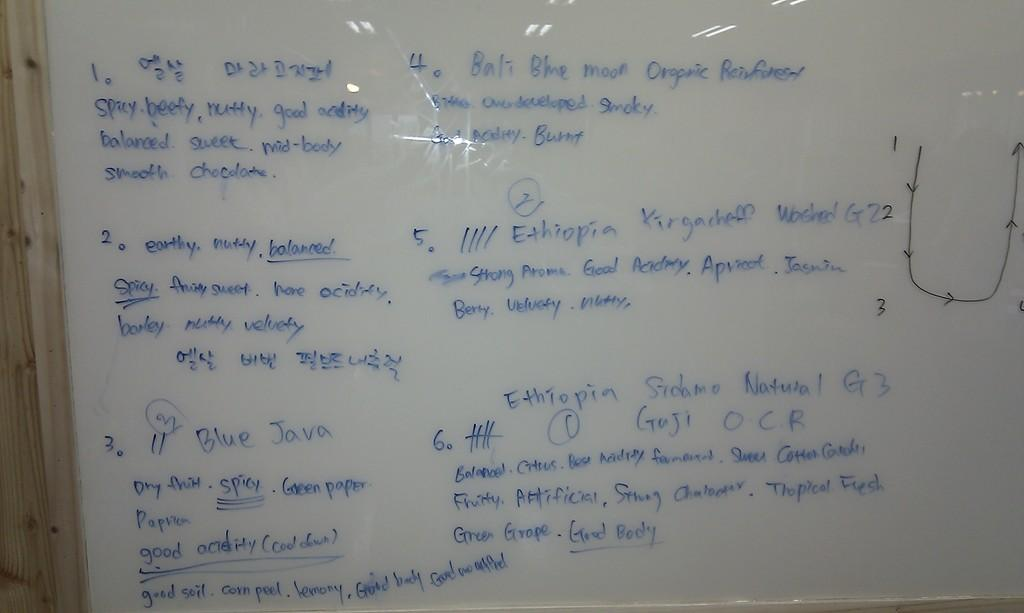What is the main object in the image? There is a white color board in the image. What is written or displayed on the white color board? There is text on the white color board. How many tomatoes are on the white color board in the image? There are no tomatoes present on the white color board in the image. What type of crow can be seen interacting with the text on the white color board? There is no crow present in the image; it only features a white color board with text. 